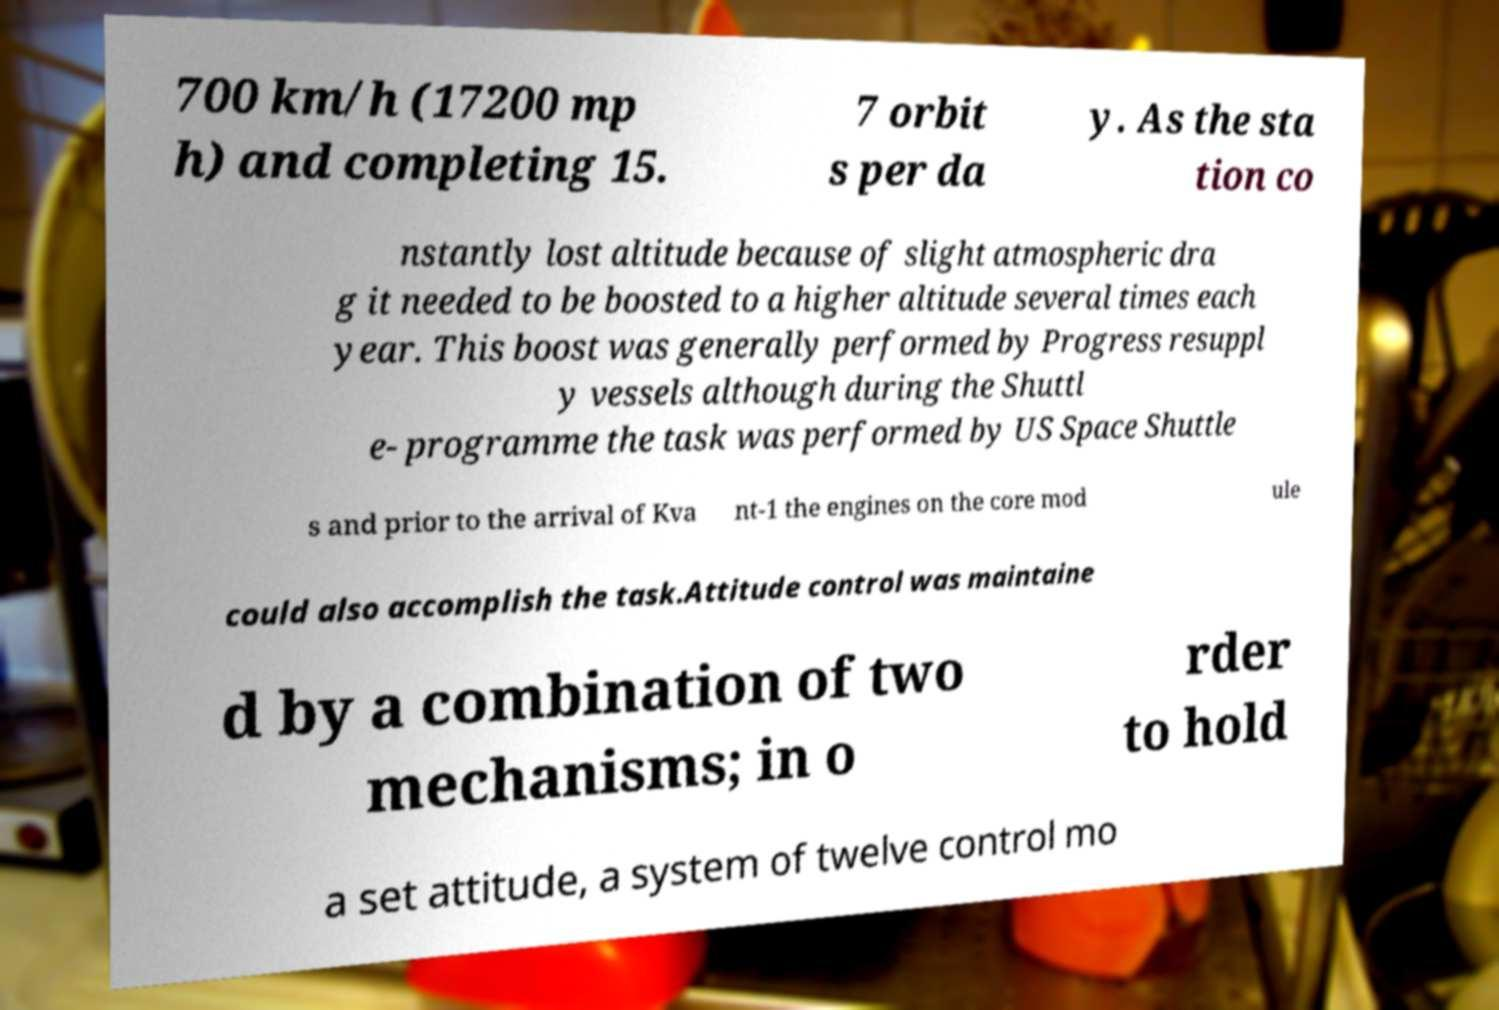Please read and relay the text visible in this image. What does it say? 700 km/h (17200 mp h) and completing 15. 7 orbit s per da y. As the sta tion co nstantly lost altitude because of slight atmospheric dra g it needed to be boosted to a higher altitude several times each year. This boost was generally performed by Progress resuppl y vessels although during the Shuttl e- programme the task was performed by US Space Shuttle s and prior to the arrival of Kva nt-1 the engines on the core mod ule could also accomplish the task.Attitude control was maintaine d by a combination of two mechanisms; in o rder to hold a set attitude, a system of twelve control mo 